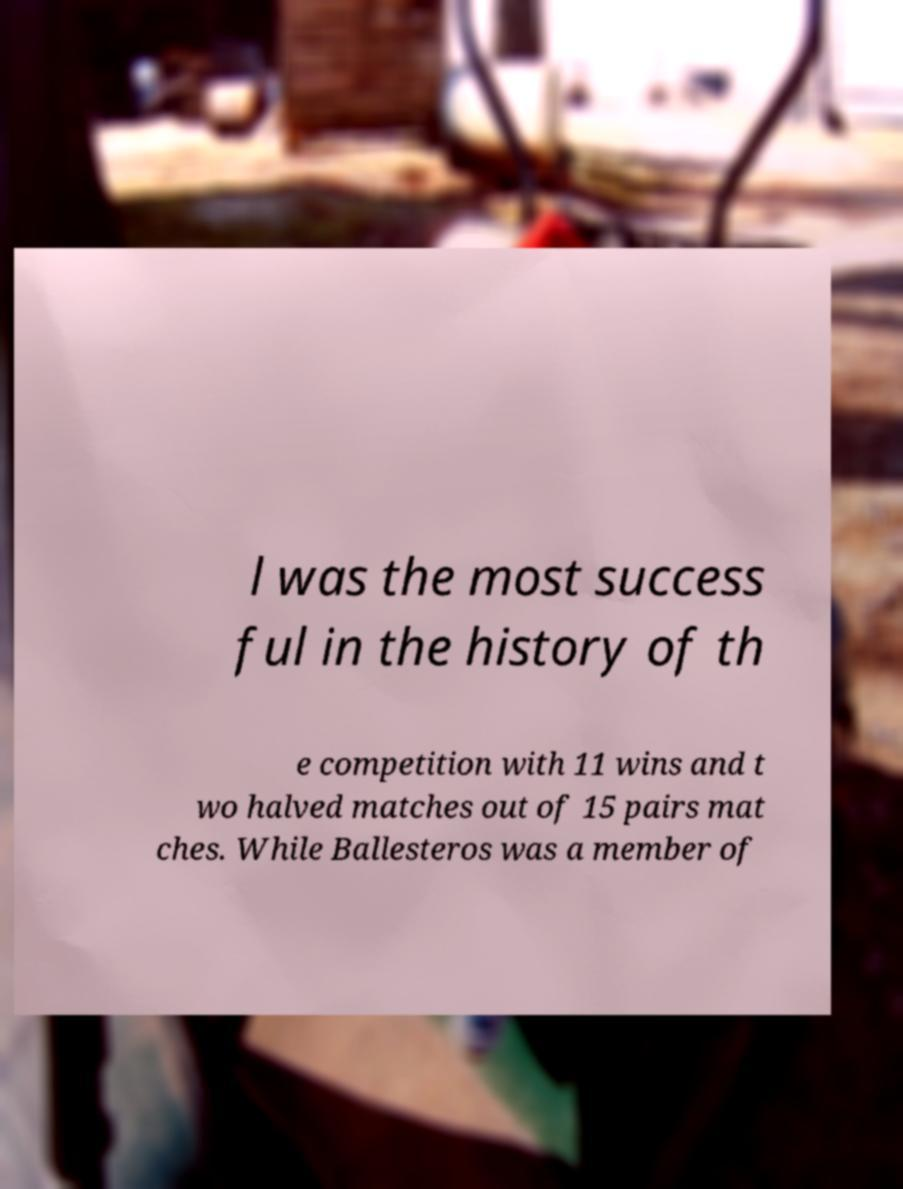Please read and relay the text visible in this image. What does it say? l was the most success ful in the history of th e competition with 11 wins and t wo halved matches out of 15 pairs mat ches. While Ballesteros was a member of 